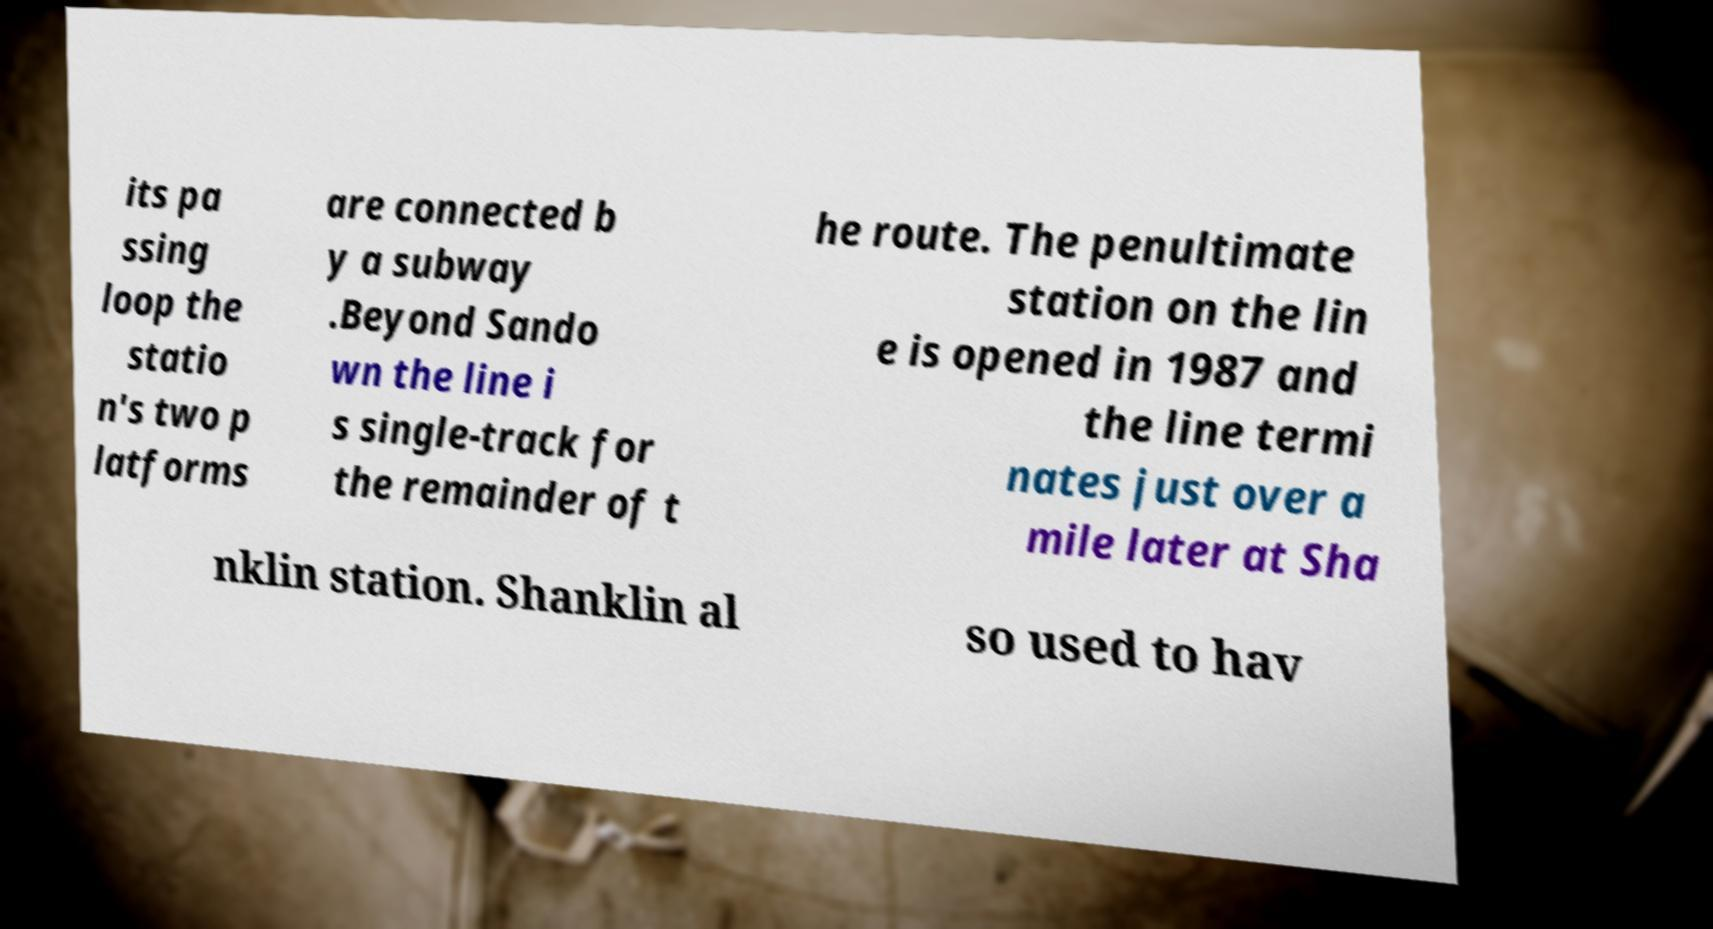Please read and relay the text visible in this image. What does it say? its pa ssing loop the statio n's two p latforms are connected b y a subway .Beyond Sando wn the line i s single-track for the remainder of t he route. The penultimate station on the lin e is opened in 1987 and the line termi nates just over a mile later at Sha nklin station. Shanklin al so used to hav 